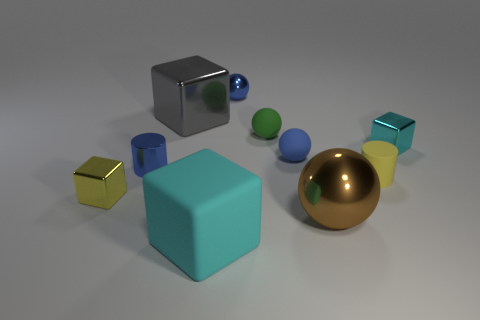Subtract all cyan cubes. How many were subtracted if there are1cyan cubes left? 1 Subtract all big rubber cubes. How many cubes are left? 3 Subtract 1 cubes. How many cubes are left? 3 Subtract all brown spheres. How many spheres are left? 3 Subtract all purple spheres. Subtract all cyan blocks. How many spheres are left? 4 Subtract all blocks. How many objects are left? 6 Subtract 1 blue spheres. How many objects are left? 9 Subtract all gray matte things. Subtract all tiny green rubber balls. How many objects are left? 9 Add 1 big gray cubes. How many big gray cubes are left? 2 Add 5 spheres. How many spheres exist? 9 